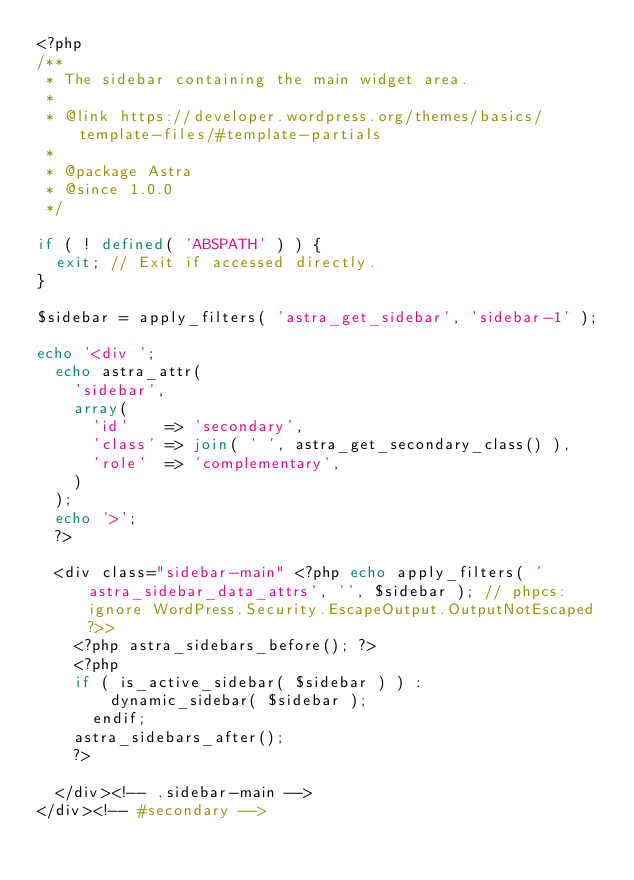<code> <loc_0><loc_0><loc_500><loc_500><_PHP_><?php
/**
 * The sidebar containing the main widget area.
 *
 * @link https://developer.wordpress.org/themes/basics/template-files/#template-partials
 *
 * @package Astra
 * @since 1.0.0
 */

if ( ! defined( 'ABSPATH' ) ) {
	exit; // Exit if accessed directly.
}

$sidebar = apply_filters( 'astra_get_sidebar', 'sidebar-1' );

echo '<div ';
	echo astra_attr(
		'sidebar',
		array(
			'id'    => 'secondary',
			'class' => join( ' ', astra_get_secondary_class() ),
			'role'  => 'complementary',
		)
	);
	echo '>';
	?>

	<div class="sidebar-main" <?php echo apply_filters( 'astra_sidebar_data_attrs', '', $sidebar ); // phpcs:ignore WordPress.Security.EscapeOutput.OutputNotEscaped ?>>
		<?php astra_sidebars_before(); ?>
		<?php 
		if ( is_active_sidebar( $sidebar ) ) :
				dynamic_sidebar( $sidebar );
			endif;
		astra_sidebars_after(); 
		?>

	</div><!-- .sidebar-main -->
</div><!-- #secondary -->
</code> 